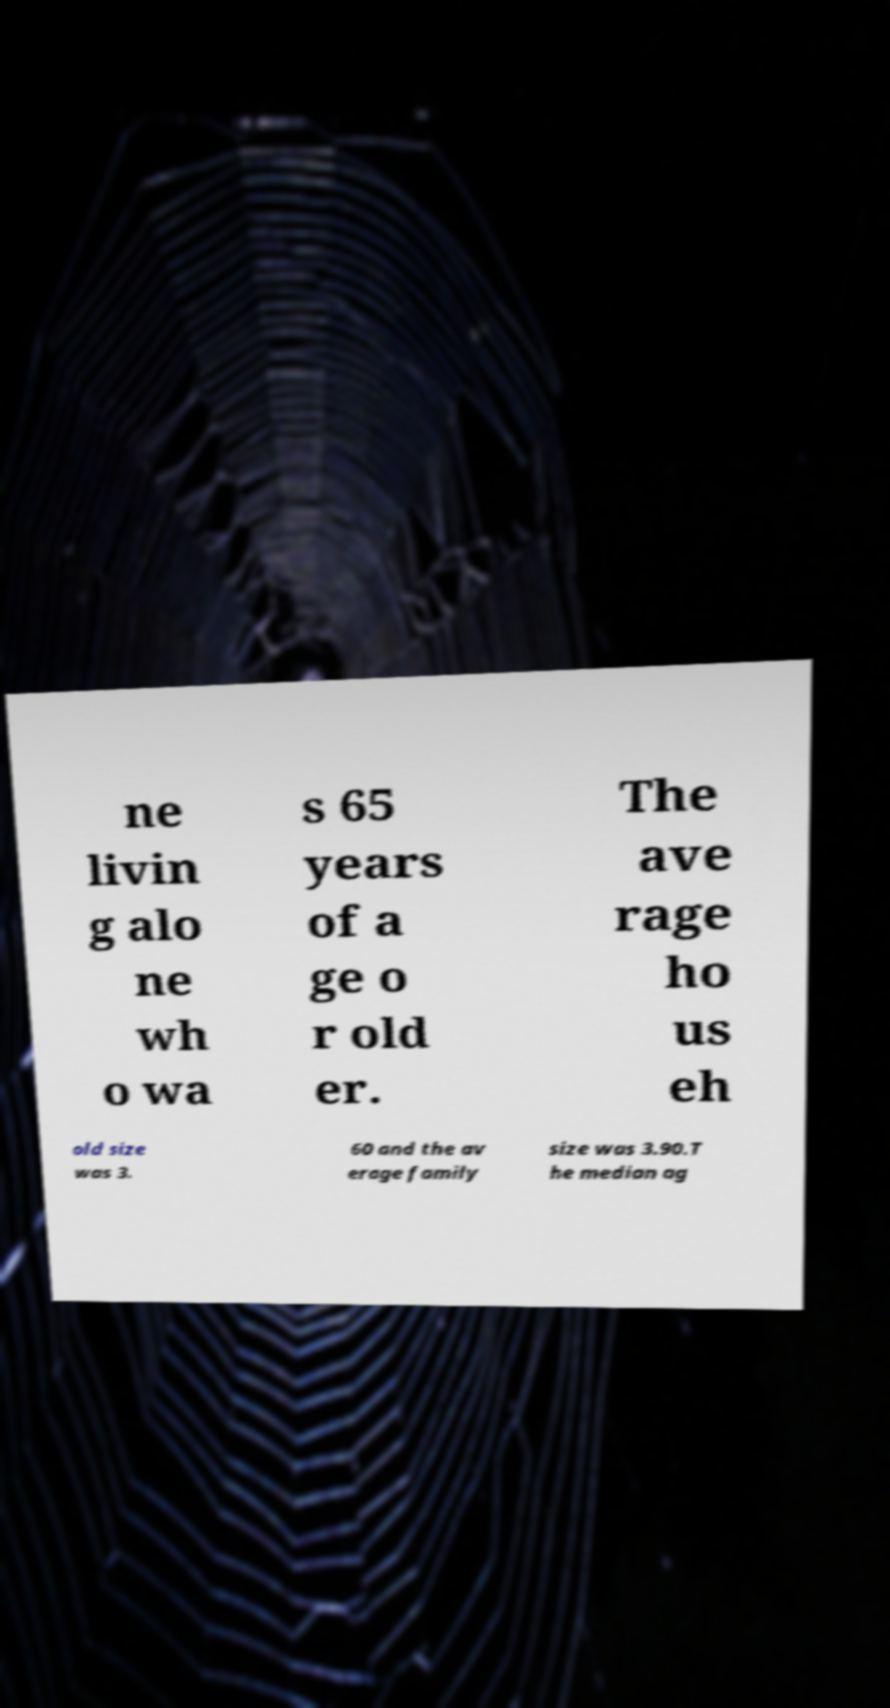For documentation purposes, I need the text within this image transcribed. Could you provide that? ne livin g alo ne wh o wa s 65 years of a ge o r old er. The ave rage ho us eh old size was 3. 60 and the av erage family size was 3.90.T he median ag 